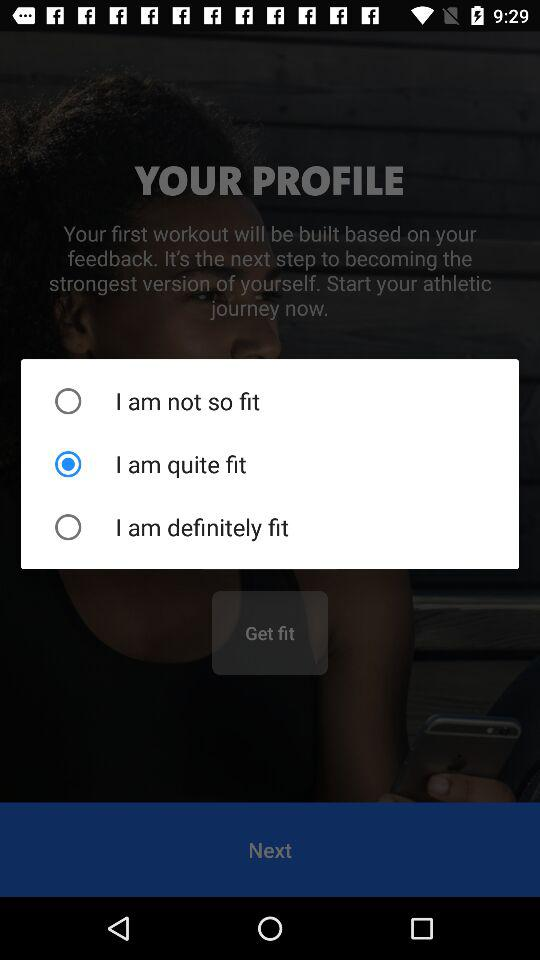Is "I am quite fit" selected or not?
Answer the question using a single word or phrase. It is selected. 